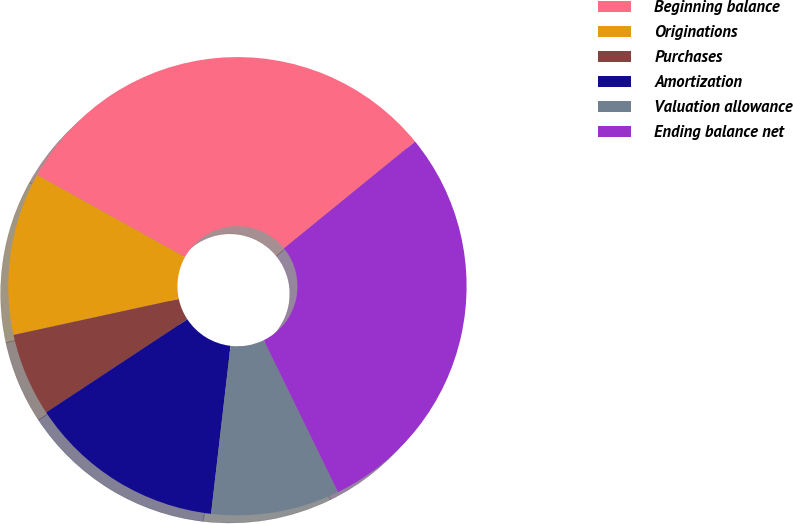Convert chart to OTSL. <chart><loc_0><loc_0><loc_500><loc_500><pie_chart><fcel>Beginning balance<fcel>Originations<fcel>Purchases<fcel>Amortization<fcel>Valuation allowance<fcel>Ending balance net<nl><fcel>31.05%<fcel>11.48%<fcel>5.87%<fcel>13.88%<fcel>9.07%<fcel>28.64%<nl></chart> 